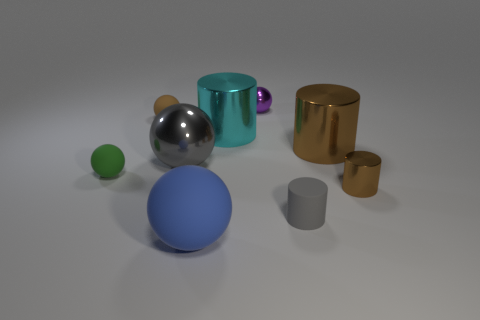There is a tiny object that is the same color as the large shiny sphere; what is its shape?
Your answer should be very brief. Cylinder. Are there any tiny balls that have the same color as the tiny metallic cylinder?
Make the answer very short. Yes. Is there anything else of the same color as the rubber cylinder?
Your response must be concise. Yes. Is the shape of the tiny shiny object in front of the tiny brown matte object the same as  the cyan metallic object?
Your response must be concise. Yes. How many objects are either small cyan cylinders or small brown things in front of the gray shiny thing?
Your answer should be compact. 1. What size is the metal cylinder that is both behind the big gray ball and on the right side of the gray cylinder?
Your answer should be very brief. Large. Are there more brown rubber objects on the left side of the tiny matte cylinder than brown shiny things that are left of the large gray shiny thing?
Give a very brief answer. Yes. There is a big blue thing; is it the same shape as the small rubber thing in front of the tiny green matte object?
Offer a terse response. No. How many other objects are there of the same shape as the purple metal object?
Give a very brief answer. 4. There is a thing that is both right of the gray rubber cylinder and behind the large gray metallic object; what color is it?
Your response must be concise. Brown. 